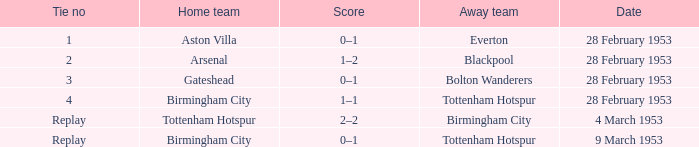What score has aston villa's home team achieved? 0–1. 